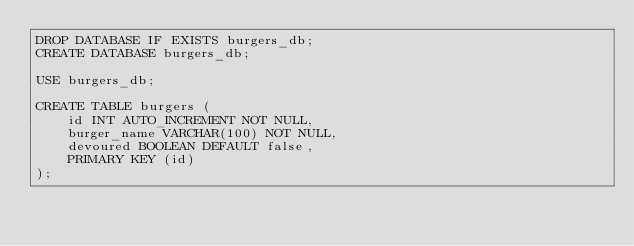Convert code to text. <code><loc_0><loc_0><loc_500><loc_500><_SQL_>DROP DATABASE IF EXISTS burgers_db;
CREATE DATABASE burgers_db;

USE burgers_db;

CREATE TABLE burgers (
    id INT AUTO_INCREMENT NOT NULL,
    burger_name VARCHAR(100) NOT NULL,
    devoured BOOLEAN DEFAULT false,
    PRIMARY KEY (id)
);</code> 